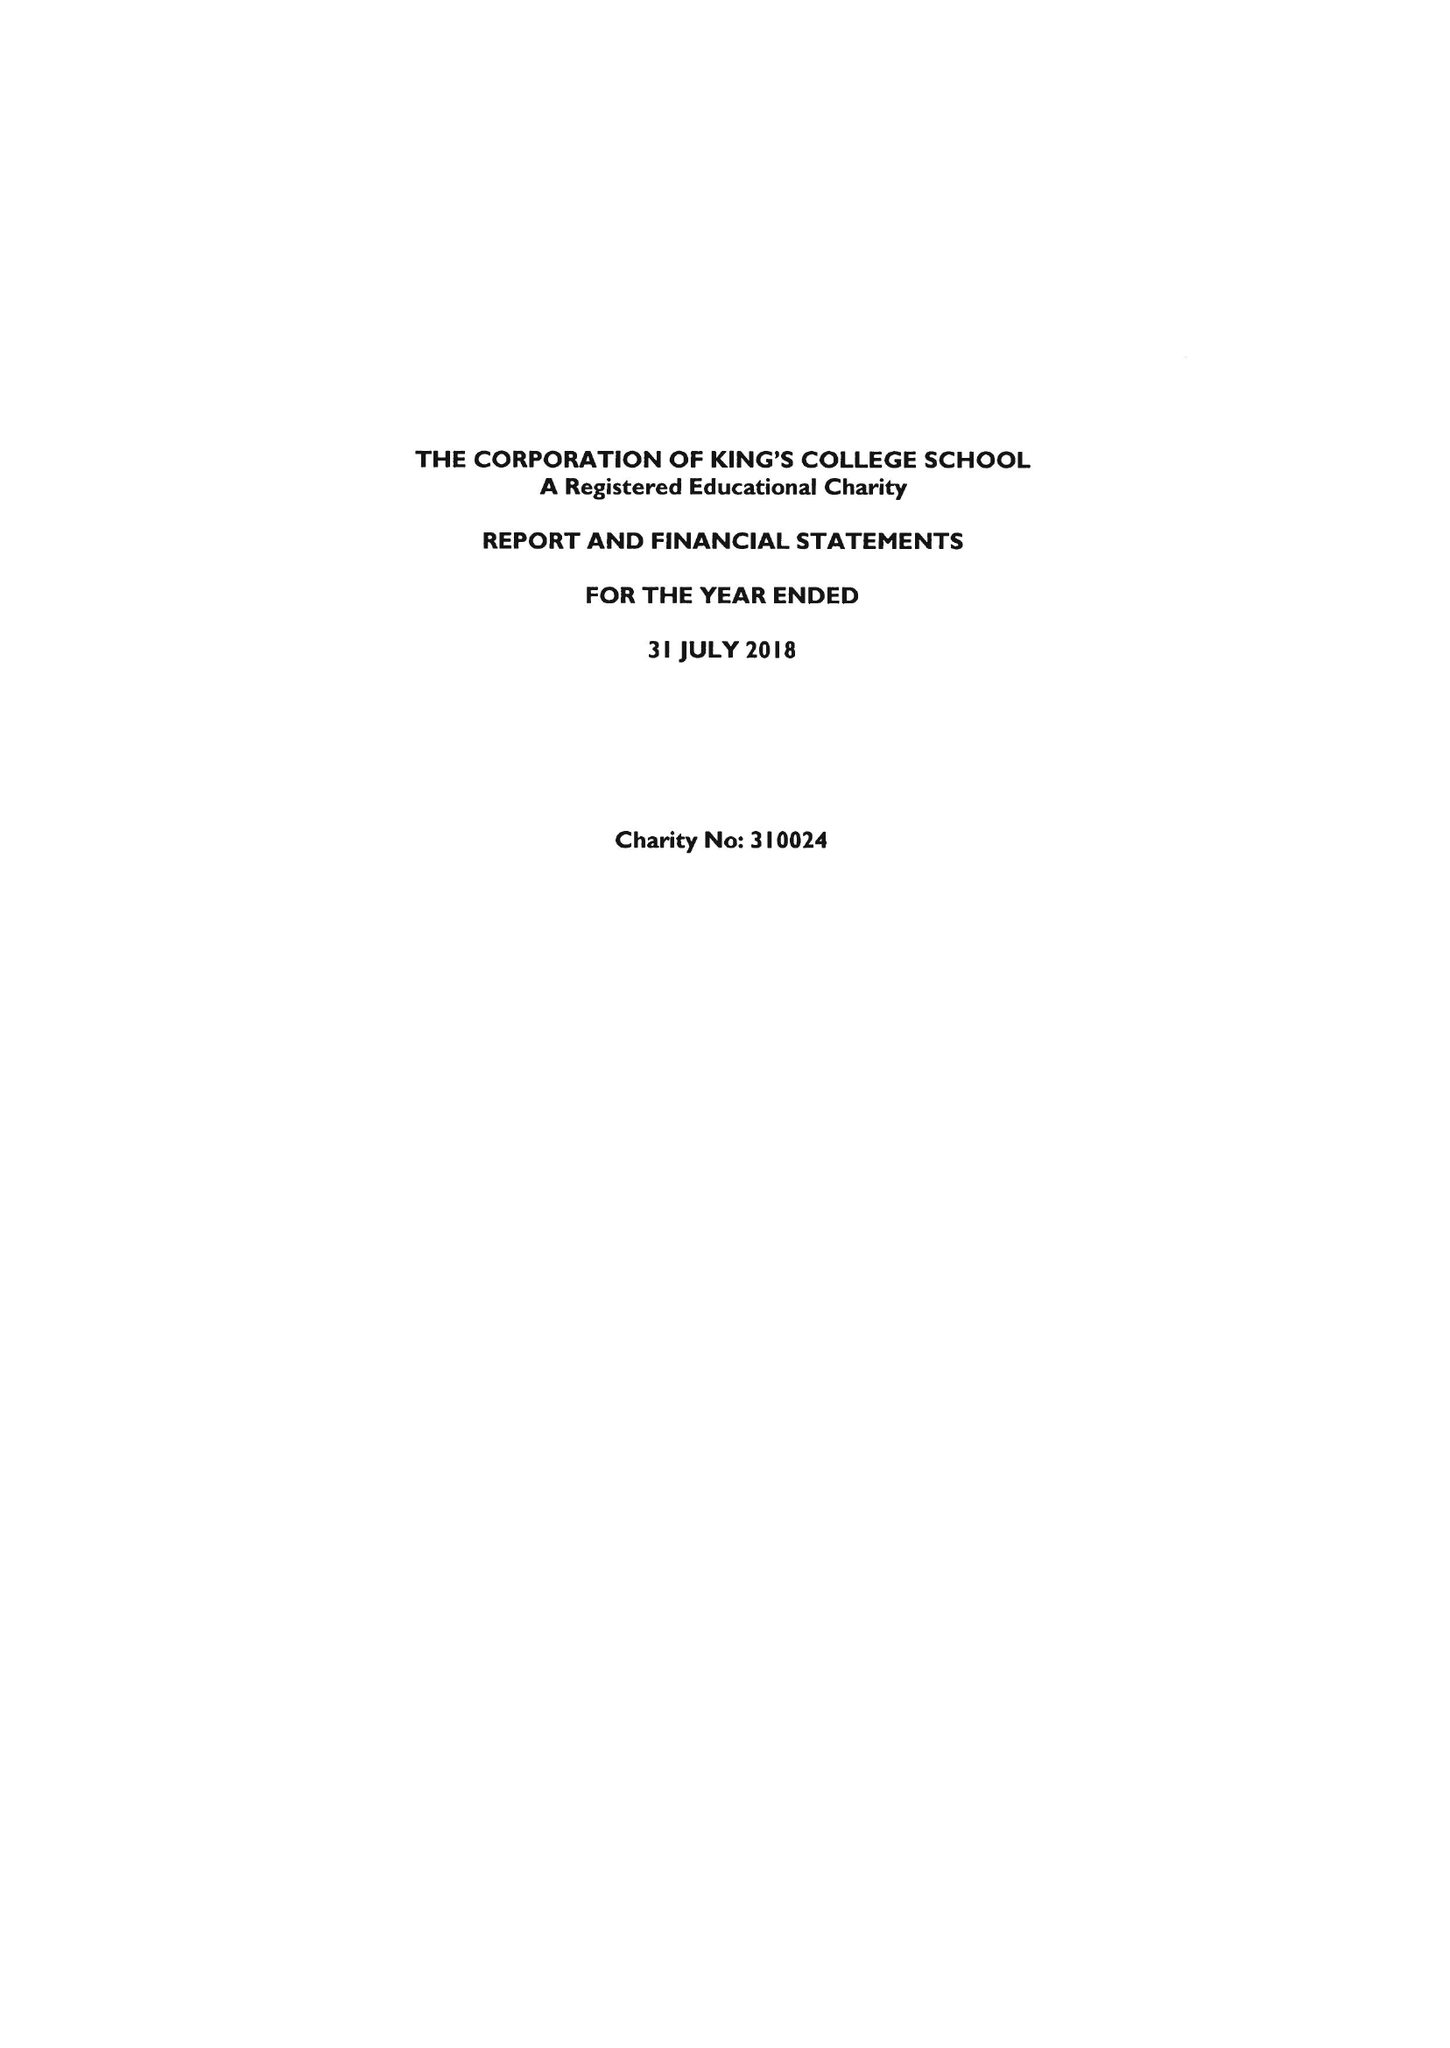What is the value for the address__street_line?
Answer the question using a single word or phrase. SOUTHSIDE COMMON 